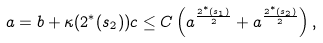<formula> <loc_0><loc_0><loc_500><loc_500>a = b + \kappa ( 2 ^ { * } ( s _ { 2 } ) ) c \leq C \left ( a ^ { \frac { 2 ^ { * } ( s _ { 1 } ) } { 2 } } + a ^ { \frac { 2 ^ { * } ( s _ { 2 } ) } { 2 } } \right ) ,</formula> 